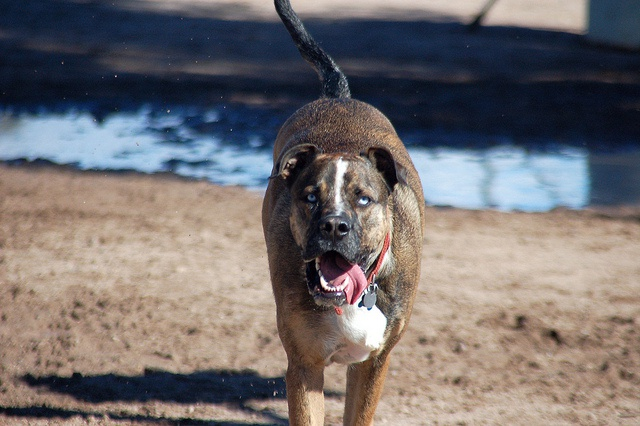Describe the objects in this image and their specific colors. I can see a dog in black, gray, maroon, and darkgray tones in this image. 